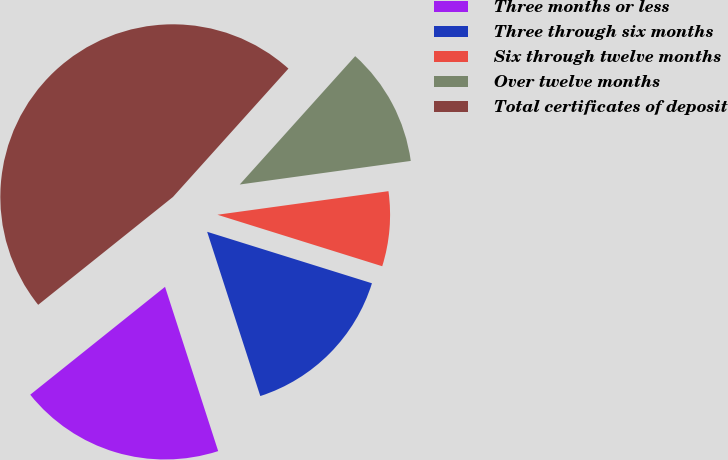Convert chart. <chart><loc_0><loc_0><loc_500><loc_500><pie_chart><fcel>Three months or less<fcel>Three through six months<fcel>Six through twelve months<fcel>Over twelve months<fcel>Total certificates of deposit<nl><fcel>19.24%<fcel>15.2%<fcel>7.0%<fcel>11.16%<fcel>47.4%<nl></chart> 